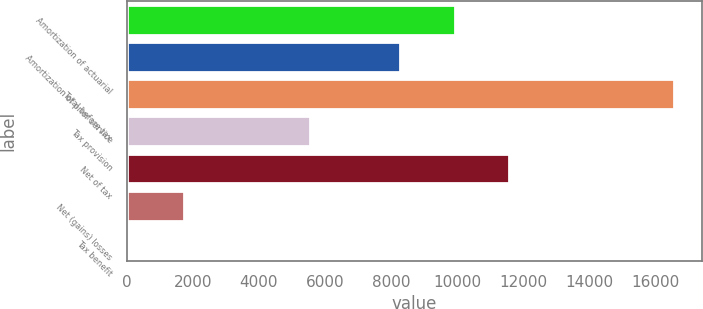<chart> <loc_0><loc_0><loc_500><loc_500><bar_chart><fcel>Amortization of actuarial<fcel>Amortization of prior service<fcel>Total before tax<fcel>Tax provision<fcel>Net of tax<fcel>Net (gains) losses<fcel>Tax benefit<nl><fcel>9935<fcel>8283<fcel>16587<fcel>5551<fcel>11587<fcel>1719<fcel>67<nl></chart> 